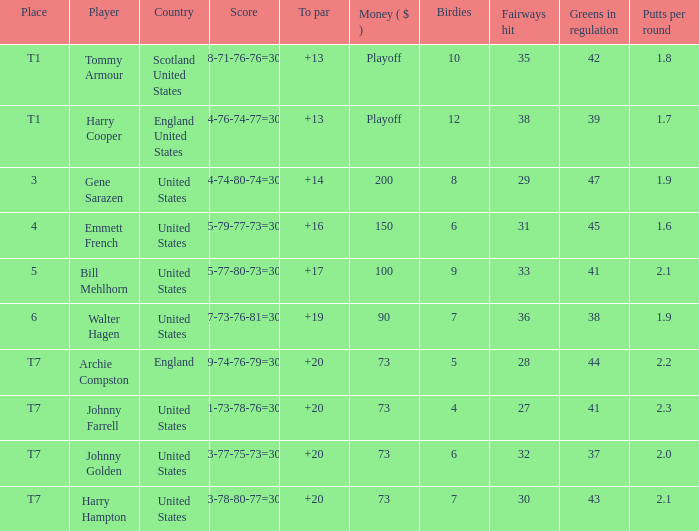What is the ranking for the United States when the money is $200? 3.0. 